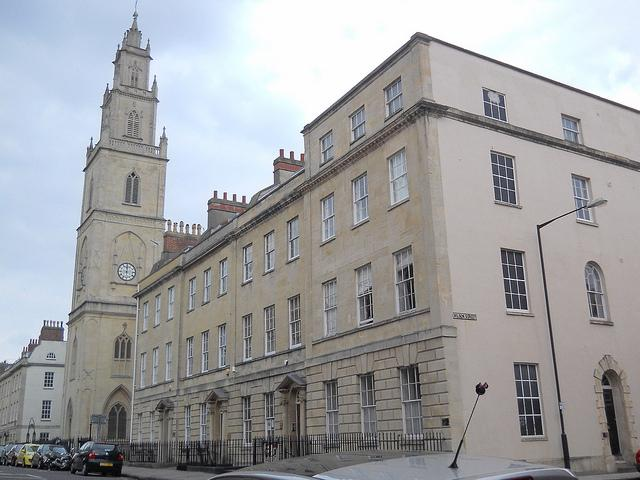What color are the chimney pieces on the top of the long rectangular house?

Choices:
A) blue
B) green
C) red
D) yellow red 